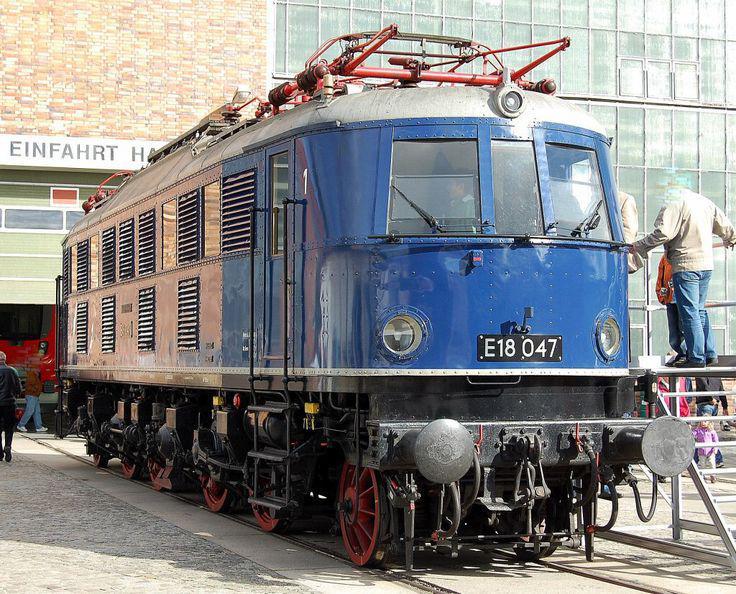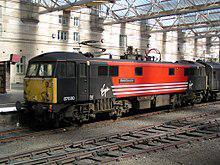The first image is the image on the left, the second image is the image on the right. For the images shown, is this caption "A train with three windows across the front is angled so it points right." true? Answer yes or no. Yes. The first image is the image on the left, the second image is the image on the right. Assess this claim about the two images: "There is a blue train facing right.". Correct or not? Answer yes or no. Yes. 